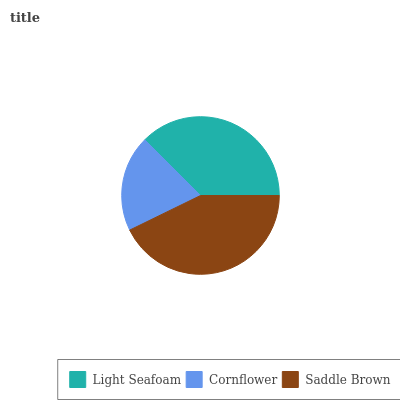Is Cornflower the minimum?
Answer yes or no. Yes. Is Saddle Brown the maximum?
Answer yes or no. Yes. Is Saddle Brown the minimum?
Answer yes or no. No. Is Cornflower the maximum?
Answer yes or no. No. Is Saddle Brown greater than Cornflower?
Answer yes or no. Yes. Is Cornflower less than Saddle Brown?
Answer yes or no. Yes. Is Cornflower greater than Saddle Brown?
Answer yes or no. No. Is Saddle Brown less than Cornflower?
Answer yes or no. No. Is Light Seafoam the high median?
Answer yes or no. Yes. Is Light Seafoam the low median?
Answer yes or no. Yes. Is Saddle Brown the high median?
Answer yes or no. No. Is Saddle Brown the low median?
Answer yes or no. No. 